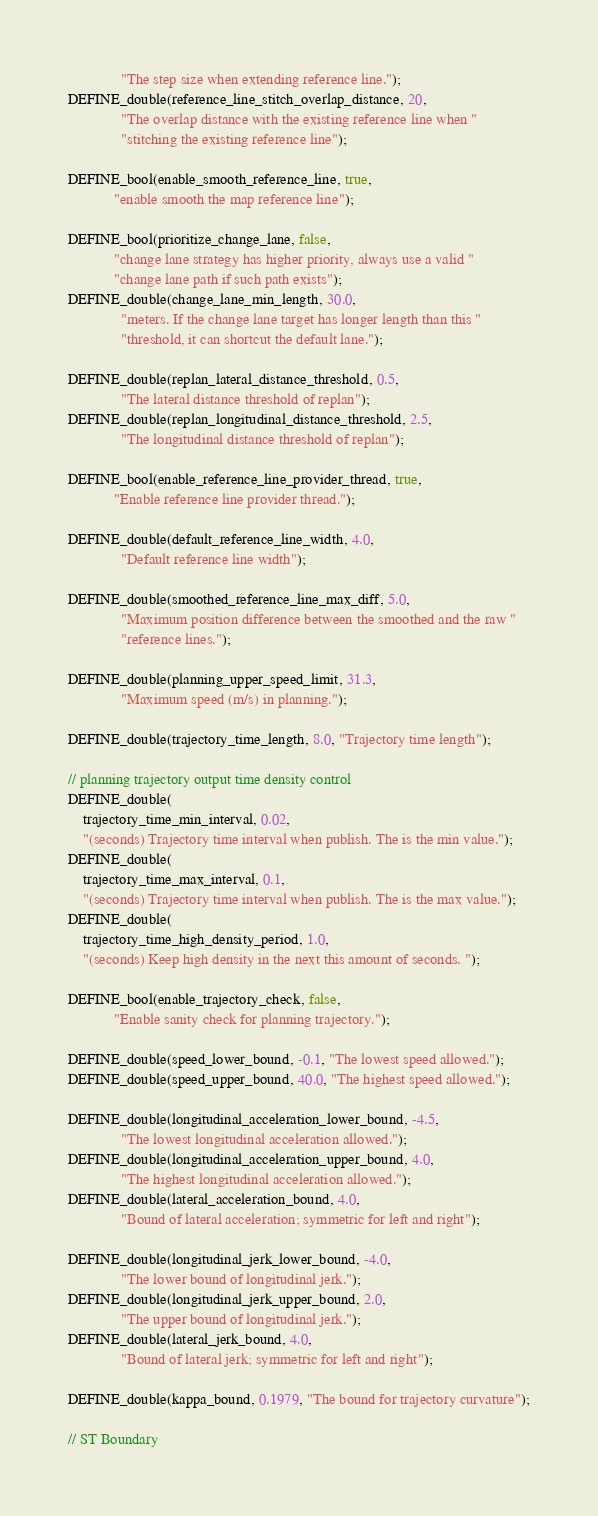<code> <loc_0><loc_0><loc_500><loc_500><_C++_>              "The step size when extending reference line.");
DEFINE_double(reference_line_stitch_overlap_distance, 20,
              "The overlap distance with the existing reference line when "
              "stitching the existing reference line");

DEFINE_bool(enable_smooth_reference_line, true,
            "enable smooth the map reference line");

DEFINE_bool(prioritize_change_lane, false,
            "change lane strategy has higher priority, always use a valid "
            "change lane path if such path exists");
DEFINE_double(change_lane_min_length, 30.0,
              "meters. If the change lane target has longer length than this "
              "threshold, it can shortcut the default lane.");

DEFINE_double(replan_lateral_distance_threshold, 0.5,
              "The lateral distance threshold of replan");
DEFINE_double(replan_longitudinal_distance_threshold, 2.5,
              "The longitudinal distance threshold of replan");

DEFINE_bool(enable_reference_line_provider_thread, true,
            "Enable reference line provider thread.");

DEFINE_double(default_reference_line_width, 4.0,
              "Default reference line width");

DEFINE_double(smoothed_reference_line_max_diff, 5.0,
              "Maximum position difference between the smoothed and the raw "
              "reference lines.");

DEFINE_double(planning_upper_speed_limit, 31.3,
              "Maximum speed (m/s) in planning.");

DEFINE_double(trajectory_time_length, 8.0, "Trajectory time length");

// planning trajectory output time density control
DEFINE_double(
    trajectory_time_min_interval, 0.02,
    "(seconds) Trajectory time interval when publish. The is the min value.");
DEFINE_double(
    trajectory_time_max_interval, 0.1,
    "(seconds) Trajectory time interval when publish. The is the max value.");
DEFINE_double(
    trajectory_time_high_density_period, 1.0,
    "(seconds) Keep high density in the next this amount of seconds. ");

DEFINE_bool(enable_trajectory_check, false,
            "Enable sanity check for planning trajectory.");

DEFINE_double(speed_lower_bound, -0.1, "The lowest speed allowed.");
DEFINE_double(speed_upper_bound, 40.0, "The highest speed allowed.");

DEFINE_double(longitudinal_acceleration_lower_bound, -4.5,
              "The lowest longitudinal acceleration allowed.");
DEFINE_double(longitudinal_acceleration_upper_bound, 4.0,
              "The highest longitudinal acceleration allowed.");
DEFINE_double(lateral_acceleration_bound, 4.0,
              "Bound of lateral acceleration; symmetric for left and right");

DEFINE_double(longitudinal_jerk_lower_bound, -4.0,
              "The lower bound of longitudinal jerk.");
DEFINE_double(longitudinal_jerk_upper_bound, 2.0,
              "The upper bound of longitudinal jerk.");
DEFINE_double(lateral_jerk_bound, 4.0,
              "Bound of lateral jerk; symmetric for left and right");

DEFINE_double(kappa_bound, 0.1979, "The bound for trajectory curvature");

// ST Boundary</code> 